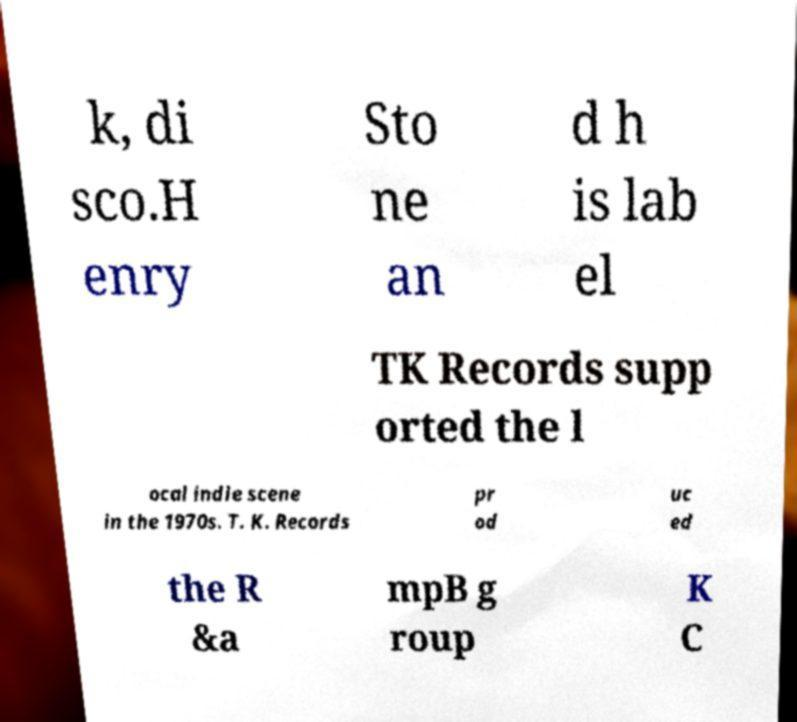Can you accurately transcribe the text from the provided image for me? k, di sco.H enry Sto ne an d h is lab el TK Records supp orted the l ocal indie scene in the 1970s. T. K. Records pr od uc ed the R &a mpB g roup K C 